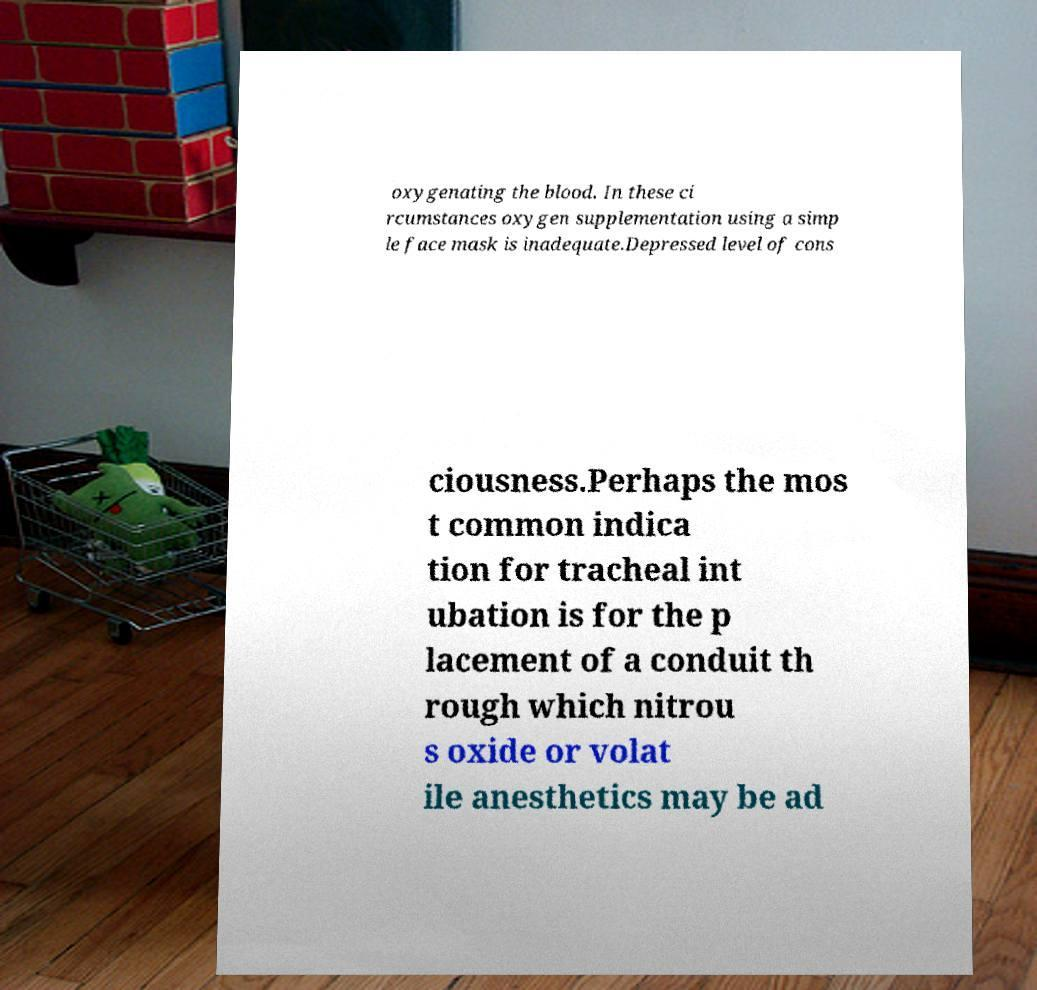Please read and relay the text visible in this image. What does it say? oxygenating the blood. In these ci rcumstances oxygen supplementation using a simp le face mask is inadequate.Depressed level of cons ciousness.Perhaps the mos t common indica tion for tracheal int ubation is for the p lacement of a conduit th rough which nitrou s oxide or volat ile anesthetics may be ad 